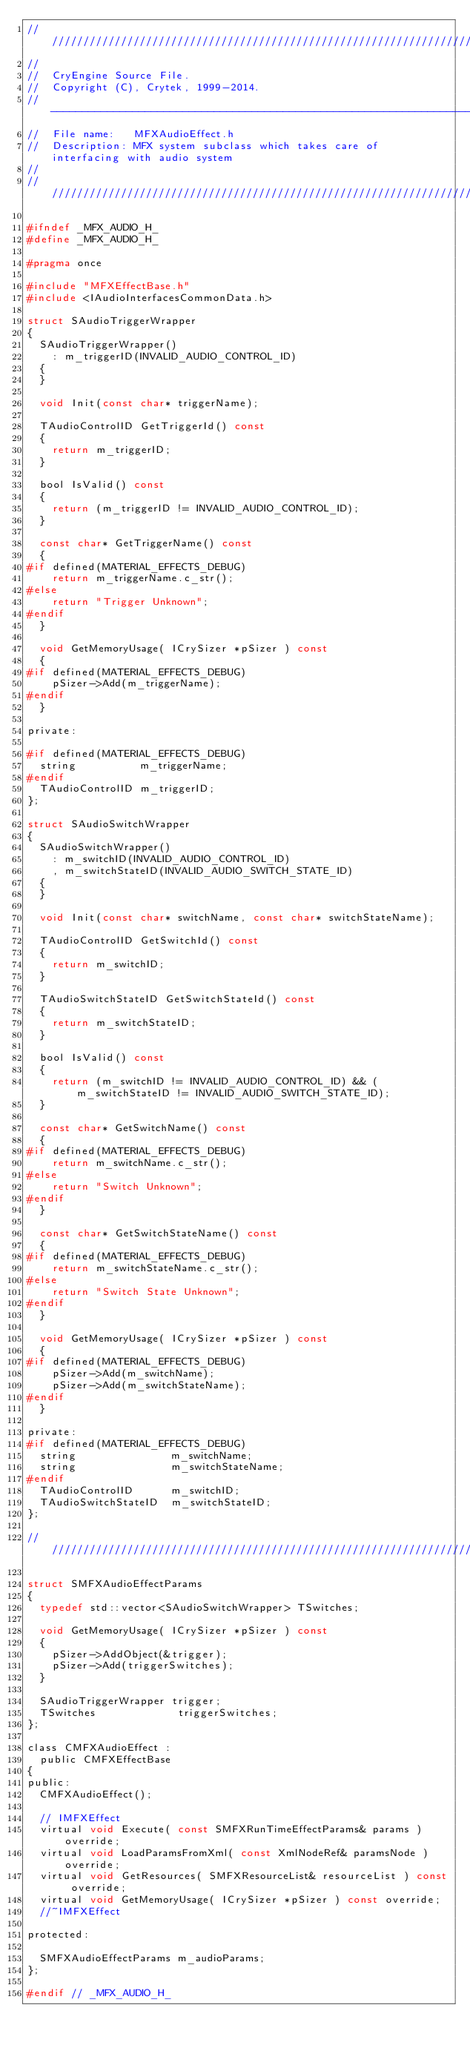Convert code to text. <code><loc_0><loc_0><loc_500><loc_500><_C_>////////////////////////////////////////////////////////////////////////////////////////////
//
//  CryEngine Source File.
//  Copyright (C), Crytek, 1999-2014.
// ----------------------------------------------------------------------------------------
//  File name:   MFXAudioEffect.h
//  Description: MFX system subclass which takes care of interfacing with audio system
//
//////////////////////////////////////////////////////////////////////////////////////////// 

#ifndef _MFX_AUDIO_H_
#define _MFX_AUDIO_H_

#pragma once

#include "MFXEffectBase.h"
#include <IAudioInterfacesCommonData.h>

struct SAudioTriggerWrapper
{
	SAudioTriggerWrapper()
		: m_triggerID(INVALID_AUDIO_CONTROL_ID)
	{
	}

	void Init(const char* triggerName);

	TAudioControlID GetTriggerId() const 
	{ 
		return m_triggerID;
	} 

	bool IsValid() const
	{
		return (m_triggerID != INVALID_AUDIO_CONTROL_ID);
	}

	const char* GetTriggerName() const
	{
#if defined(MATERIAL_EFFECTS_DEBUG)
		return m_triggerName.c_str();
#else
		return "Trigger Unknown";
#endif
	}

	void GetMemoryUsage( ICrySizer *pSizer ) const
	{
#if defined(MATERIAL_EFFECTS_DEBUG)
		pSizer->Add(m_triggerName);
#endif
	}

private:
	
#if defined(MATERIAL_EFFECTS_DEBUG)
	string          m_triggerName;
#endif
	TAudioControlID m_triggerID;
};

struct SAudioSwitchWrapper
{
	SAudioSwitchWrapper()
		: m_switchID(INVALID_AUDIO_CONTROL_ID) 
		, m_switchStateID(INVALID_AUDIO_SWITCH_STATE_ID)
	{
	}

	void Init(const char* switchName, const char* switchStateName);

	TAudioControlID GetSwitchId() const 
	{ 
		return m_switchID;
	} 

	TAudioSwitchStateID GetSwitchStateId() const 
	{ 
		return m_switchStateID;
	} 

	bool IsValid() const
	{
		return (m_switchID != INVALID_AUDIO_CONTROL_ID) && (m_switchStateID != INVALID_AUDIO_SWITCH_STATE_ID);
	}

	const char* GetSwitchName() const
	{
#if defined(MATERIAL_EFFECTS_DEBUG)
		return m_switchName.c_str();
#else
		return "Switch Unknown";
#endif
	}

	const char* GetSwitchStateName() const
	{
#if defined(MATERIAL_EFFECTS_DEBUG)
		return m_switchStateName.c_str();
#else
		return "Switch State Unknown";
#endif
	}

	void GetMemoryUsage( ICrySizer *pSizer ) const
	{
#if defined(MATERIAL_EFFECTS_DEBUG)
		pSizer->Add(m_switchName);
		pSizer->Add(m_switchStateName);
#endif
	}

private:
#if defined(MATERIAL_EFFECTS_DEBUG)
	string               m_switchName;
	string               m_switchStateName;
#endif
	TAudioControlID      m_switchID;
	TAudioSwitchStateID  m_switchStateID;
};

//////////////////////////////////////////////////////////////////////////

struct SMFXAudioEffectParams 
{
	typedef std::vector<SAudioSwitchWrapper> TSwitches;

	void GetMemoryUsage( ICrySizer *pSizer ) const
	{
		pSizer->AddObject(&trigger);
		pSizer->Add(triggerSwitches);
	}

	SAudioTriggerWrapper trigger;
	TSwitches             triggerSwitches;
};

class CMFXAudioEffect :
	public CMFXEffectBase
{
public:
	CMFXAudioEffect();

	// IMFXEffect
	virtual void Execute( const SMFXRunTimeEffectParams& params ) override;
	virtual void LoadParamsFromXml( const XmlNodeRef& paramsNode ) override;
	virtual void GetResources( SMFXResourceList& resourceList ) const override;
	virtual void GetMemoryUsage( ICrySizer *pSizer ) const override;
	//~IMFXEffect
	
protected:

	SMFXAudioEffectParams m_audioParams;
};

#endif // _MFX_AUDIO_H_

</code> 